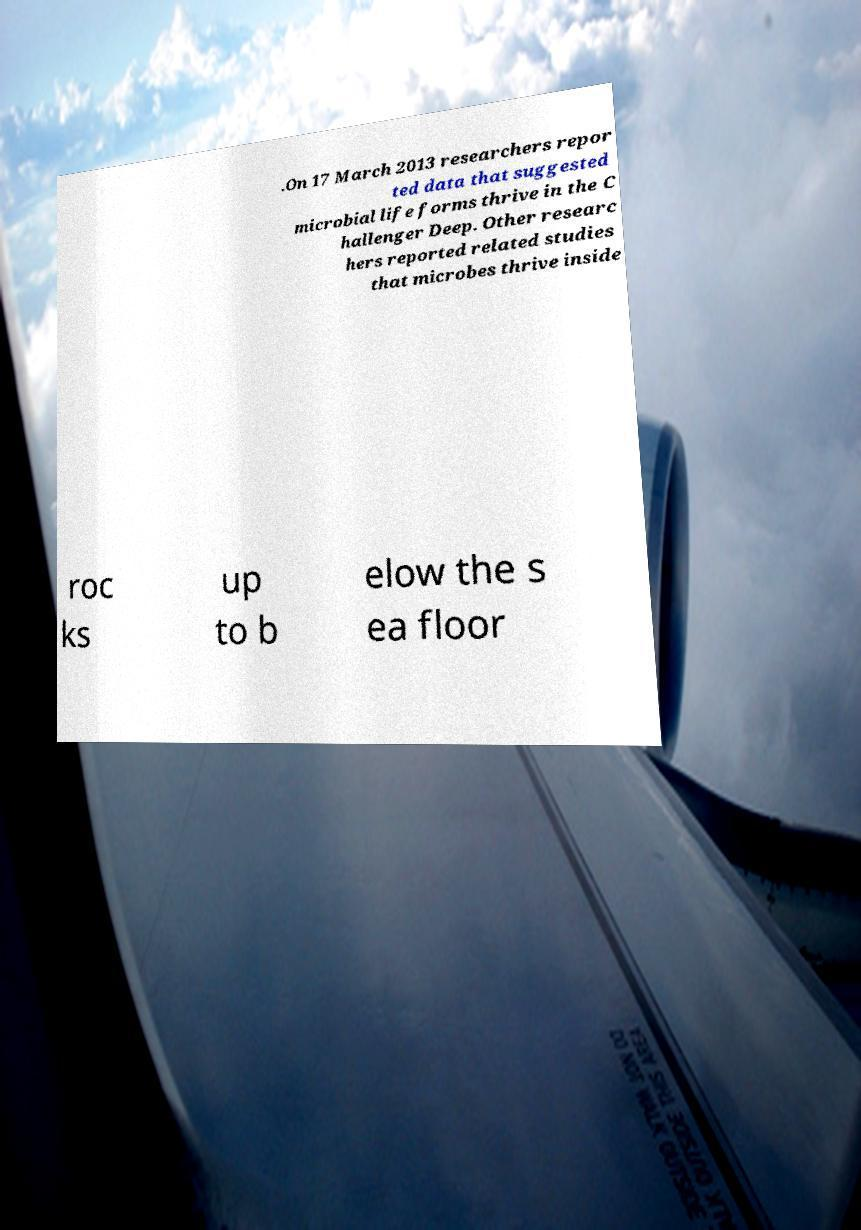Please identify and transcribe the text found in this image. .On 17 March 2013 researchers repor ted data that suggested microbial life forms thrive in the C hallenger Deep. Other researc hers reported related studies that microbes thrive inside roc ks up to b elow the s ea floor 